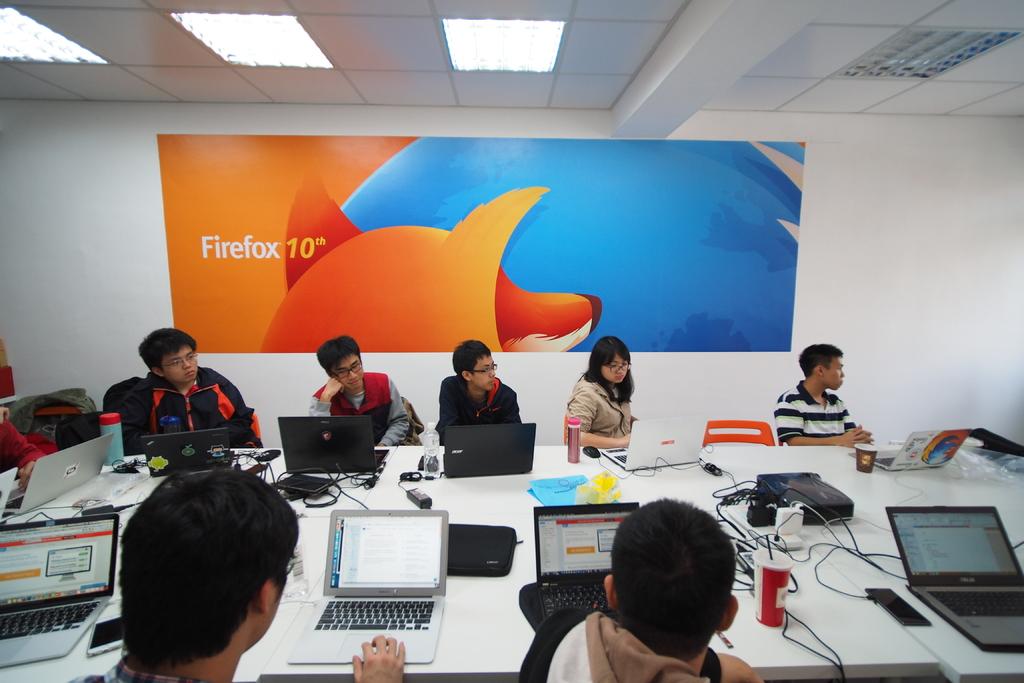Who is conducting this training session?
Keep it short and to the point. Firefox. What is the training session about?
Make the answer very short. Firefox 10. 